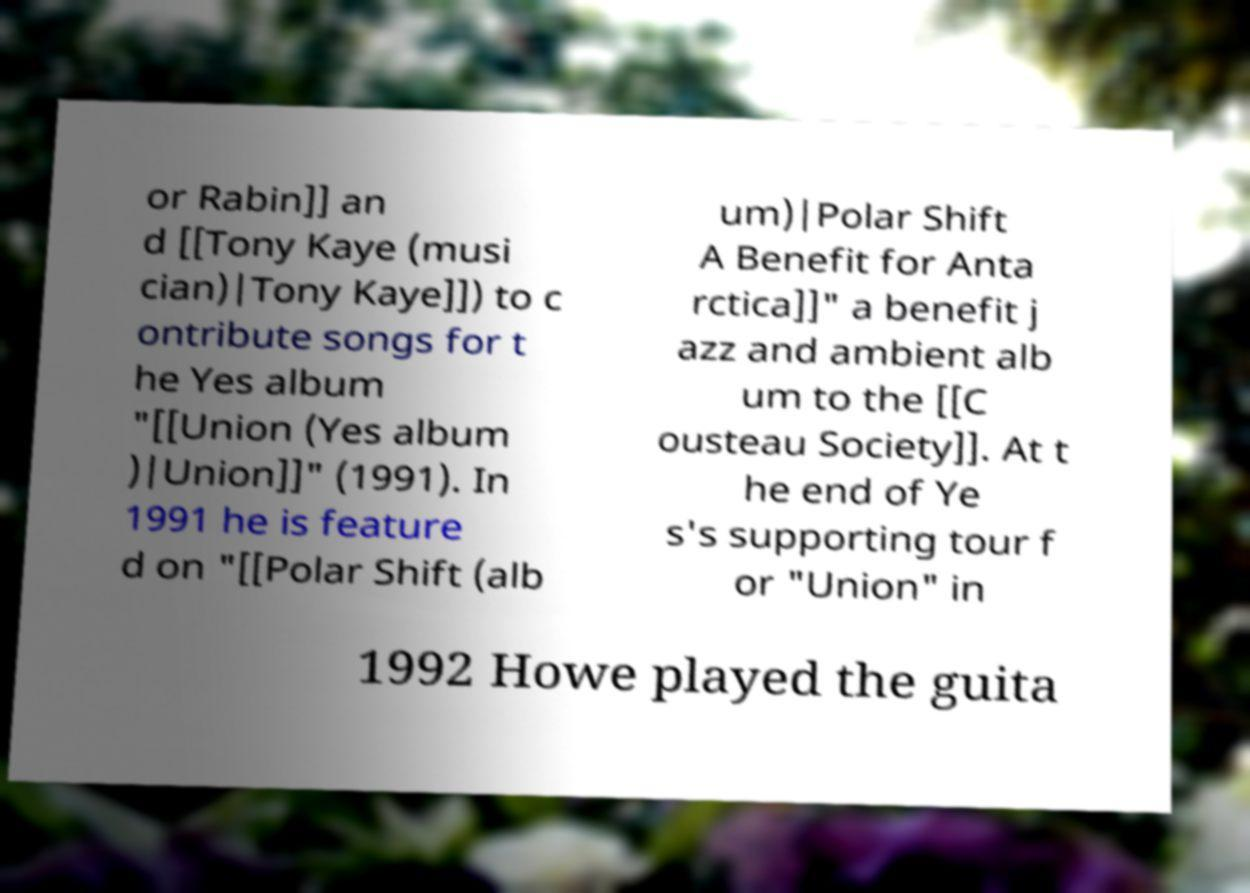Please identify and transcribe the text found in this image. or Rabin]] an d [[Tony Kaye (musi cian)|Tony Kaye]]) to c ontribute songs for t he Yes album "[[Union (Yes album )|Union]]" (1991). In 1991 he is feature d on "[[Polar Shift (alb um)|Polar Shift A Benefit for Anta rctica]]" a benefit j azz and ambient alb um to the [[C ousteau Society]]. At t he end of Ye s's supporting tour f or "Union" in 1992 Howe played the guita 